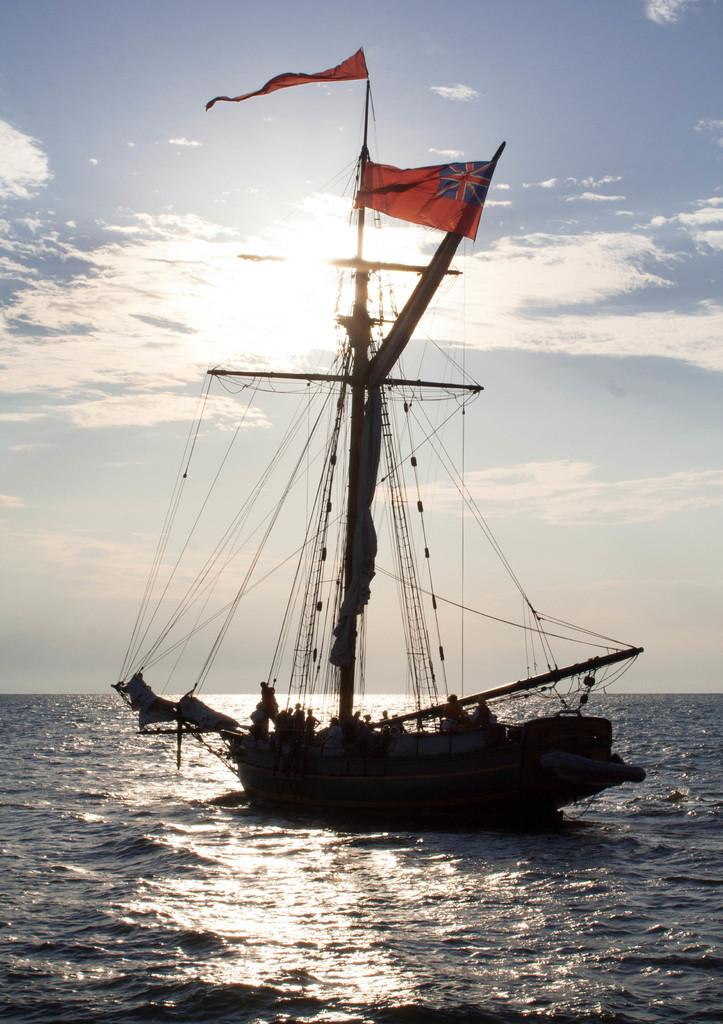What is in the water in the image? There is a boat in the water in the image. What features does the boat have? The boat has poles, ropes, and flags. Who is present in the boat? There are people in the boat. What can be seen in the background of the image? The sky is visible in the background. What type of office can be seen in the boat in the image? There is no office present in the boat or the image. Can you describe the carriage that is being pulled by the toad in the image? There is no carriage or toad present in the image. 